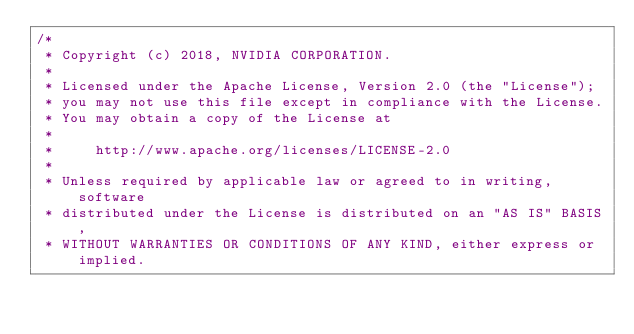Convert code to text. <code><loc_0><loc_0><loc_500><loc_500><_Cuda_>/*
 * Copyright (c) 2018, NVIDIA CORPORATION.
 *
 * Licensed under the Apache License, Version 2.0 (the "License");
 * you may not use this file except in compliance with the License.
 * You may obtain a copy of the License at
 *
 *     http://www.apache.org/licenses/LICENSE-2.0
 *
 * Unless required by applicable law or agreed to in writing, software
 * distributed under the License is distributed on an "AS IS" BASIS,
 * WITHOUT WARRANTIES OR CONDITIONS OF ANY KIND, either express or implied.</code> 